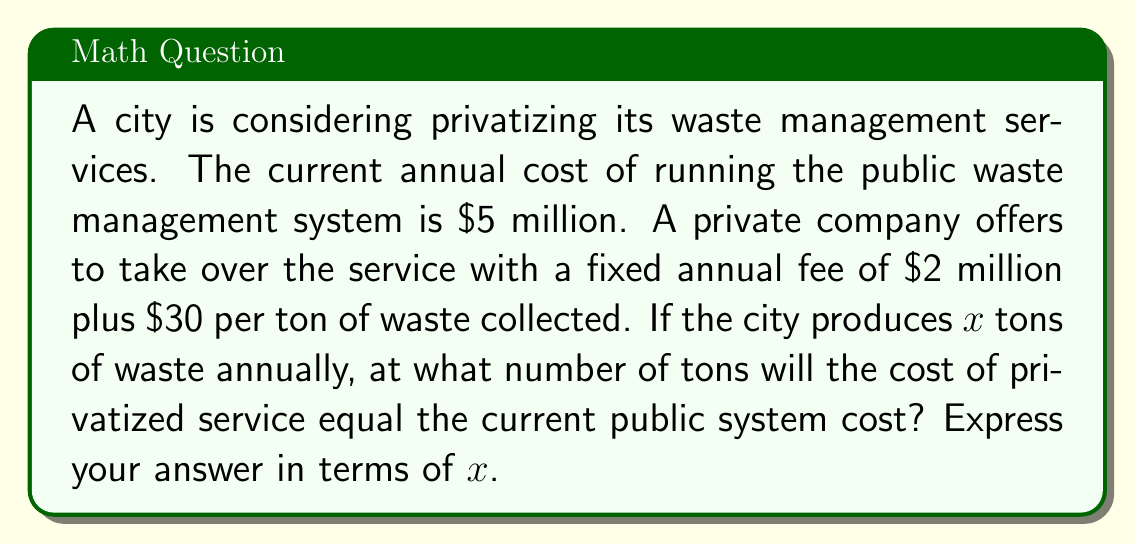Could you help me with this problem? Let's approach this step-by-step:

1) First, let's define our equations:
   
   Public system cost: $5,000,000
   Private system cost: $2,000,000 + 30x$, where $x$ is the number of tons of waste

2) At the break-even point, these costs will be equal:

   $$5,000,000 = 2,000,000 + 30x$$

3) Let's solve this equation for $x$:
   
   $$5,000,000 - 2,000,000 = 30x$$
   $$3,000,000 = 30x$$

4) Divide both sides by 30:

   $$\frac{3,000,000}{30} = x$$
   $$100,000 = x$$

5) Therefore, the break-even point occurs when the city produces 100,000 tons of waste annually.

6) We can express this in terms of $x$ as:

   $$x = 100,000$$
Answer: $x = 100,000$ 